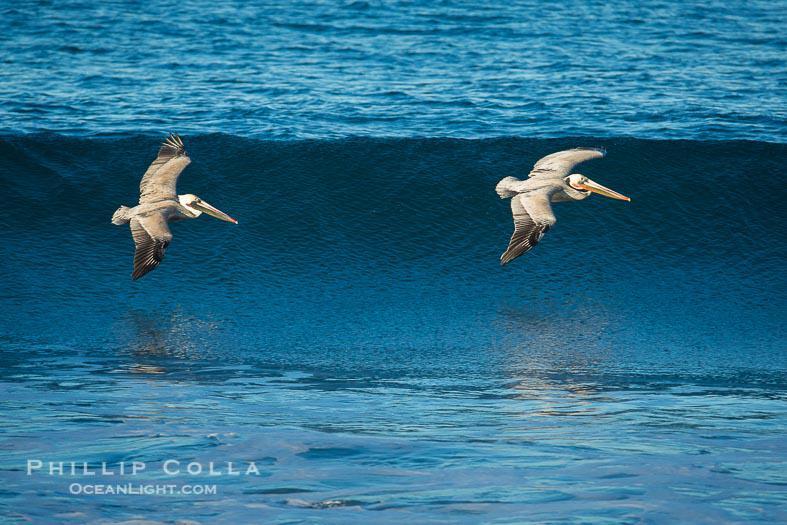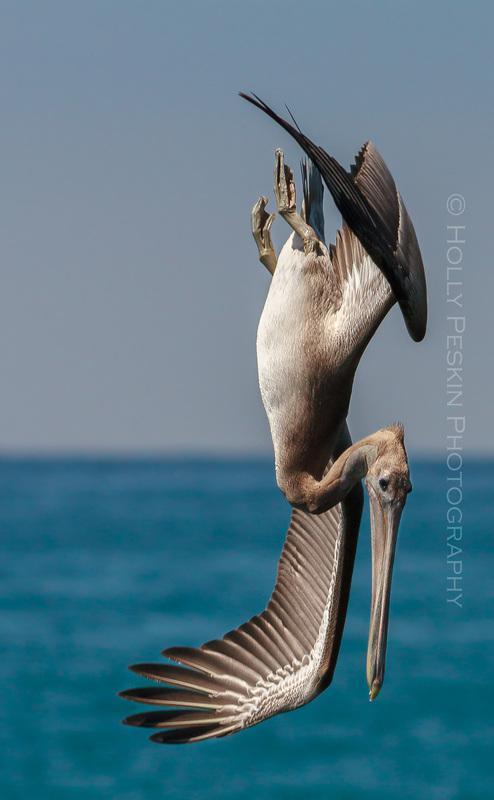The first image is the image on the left, the second image is the image on the right. Evaluate the accuracy of this statement regarding the images: "All of the pelicans are swimming.". Is it true? Answer yes or no. No. The first image is the image on the left, the second image is the image on the right. Assess this claim about the two images: "The birds in both images are swimming.". Correct or not? Answer yes or no. No. 